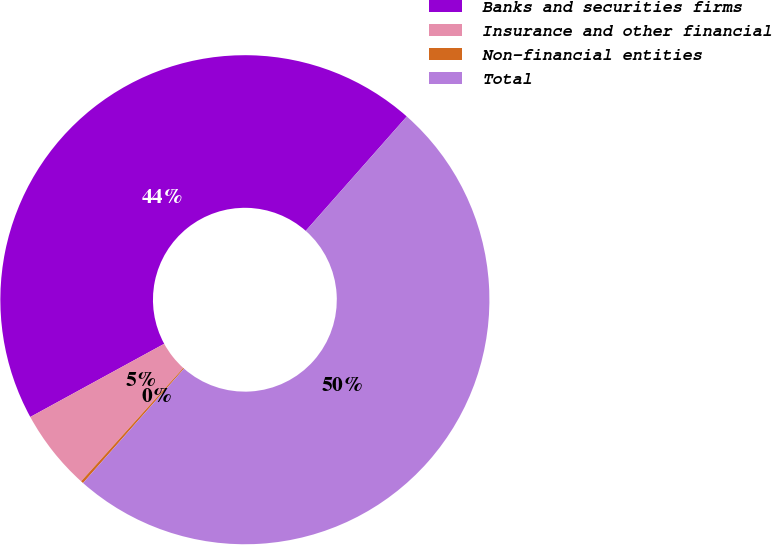<chart> <loc_0><loc_0><loc_500><loc_500><pie_chart><fcel>Banks and securities firms<fcel>Insurance and other financial<fcel>Non-financial entities<fcel>Total<nl><fcel>44.48%<fcel>5.36%<fcel>0.17%<fcel>50.0%<nl></chart> 